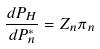<formula> <loc_0><loc_0><loc_500><loc_500>\frac { d P _ { H } } { d P ^ { * } _ { n } } = Z _ { n } \pi _ { n }</formula> 